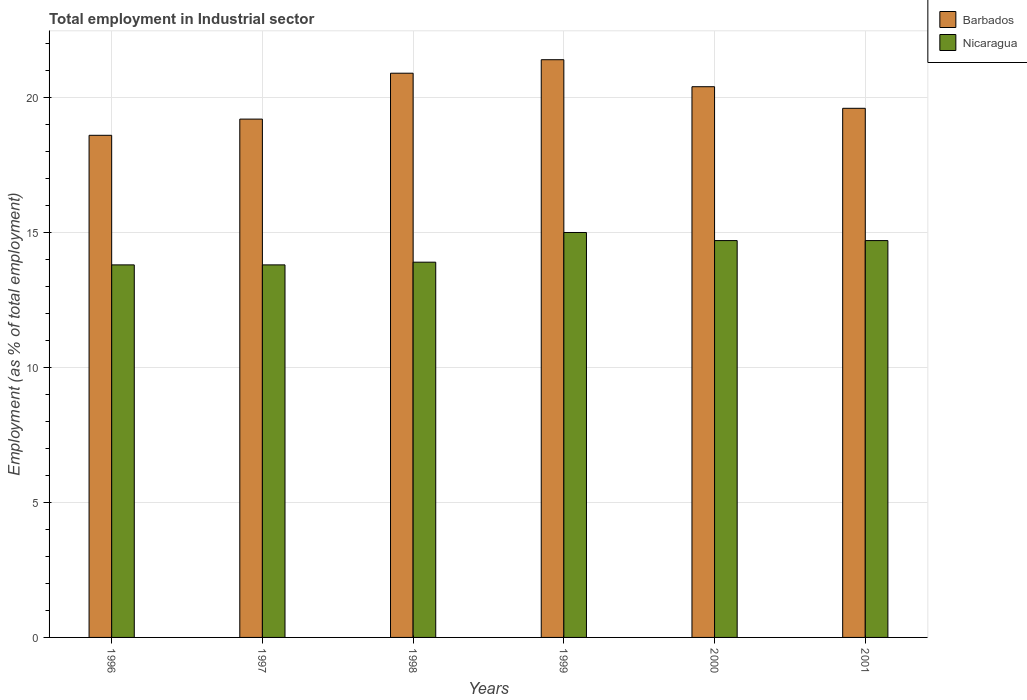How many groups of bars are there?
Your response must be concise. 6. Are the number of bars per tick equal to the number of legend labels?
Your answer should be compact. Yes. How many bars are there on the 2nd tick from the left?
Provide a succinct answer. 2. What is the label of the 5th group of bars from the left?
Ensure brevity in your answer.  2000. In how many cases, is the number of bars for a given year not equal to the number of legend labels?
Provide a succinct answer. 0. What is the employment in industrial sector in Nicaragua in 2001?
Your answer should be compact. 14.7. Across all years, what is the minimum employment in industrial sector in Nicaragua?
Your answer should be compact. 13.8. In which year was the employment in industrial sector in Barbados maximum?
Offer a terse response. 1999. In which year was the employment in industrial sector in Barbados minimum?
Provide a succinct answer. 1996. What is the total employment in industrial sector in Nicaragua in the graph?
Your response must be concise. 85.9. What is the difference between the employment in industrial sector in Barbados in 1997 and that in 2001?
Make the answer very short. -0.4. What is the difference between the employment in industrial sector in Nicaragua in 1998 and the employment in industrial sector in Barbados in 1996?
Offer a terse response. -4.7. What is the average employment in industrial sector in Nicaragua per year?
Offer a terse response. 14.32. In the year 1999, what is the difference between the employment in industrial sector in Barbados and employment in industrial sector in Nicaragua?
Offer a very short reply. 6.4. What is the ratio of the employment in industrial sector in Barbados in 1996 to that in 1997?
Give a very brief answer. 0.97. Is the difference between the employment in industrial sector in Barbados in 1998 and 1999 greater than the difference between the employment in industrial sector in Nicaragua in 1998 and 1999?
Ensure brevity in your answer.  Yes. What is the difference between the highest and the second highest employment in industrial sector in Nicaragua?
Keep it short and to the point. 0.3. What is the difference between the highest and the lowest employment in industrial sector in Nicaragua?
Offer a terse response. 1.2. Is the sum of the employment in industrial sector in Nicaragua in 2000 and 2001 greater than the maximum employment in industrial sector in Barbados across all years?
Ensure brevity in your answer.  Yes. What does the 1st bar from the left in 1998 represents?
Your response must be concise. Barbados. What does the 2nd bar from the right in 2001 represents?
Your answer should be very brief. Barbados. Are the values on the major ticks of Y-axis written in scientific E-notation?
Give a very brief answer. No. Does the graph contain grids?
Keep it short and to the point. Yes. How are the legend labels stacked?
Your answer should be very brief. Vertical. What is the title of the graph?
Make the answer very short. Total employment in Industrial sector. Does "Bolivia" appear as one of the legend labels in the graph?
Give a very brief answer. No. What is the label or title of the X-axis?
Give a very brief answer. Years. What is the label or title of the Y-axis?
Your answer should be very brief. Employment (as % of total employment). What is the Employment (as % of total employment) of Barbados in 1996?
Your response must be concise. 18.6. What is the Employment (as % of total employment) in Nicaragua in 1996?
Offer a terse response. 13.8. What is the Employment (as % of total employment) of Barbados in 1997?
Your response must be concise. 19.2. What is the Employment (as % of total employment) of Nicaragua in 1997?
Your response must be concise. 13.8. What is the Employment (as % of total employment) in Barbados in 1998?
Your response must be concise. 20.9. What is the Employment (as % of total employment) in Nicaragua in 1998?
Provide a succinct answer. 13.9. What is the Employment (as % of total employment) of Barbados in 1999?
Make the answer very short. 21.4. What is the Employment (as % of total employment) in Nicaragua in 1999?
Make the answer very short. 15. What is the Employment (as % of total employment) in Barbados in 2000?
Make the answer very short. 20.4. What is the Employment (as % of total employment) of Nicaragua in 2000?
Provide a short and direct response. 14.7. What is the Employment (as % of total employment) of Barbados in 2001?
Provide a short and direct response. 19.6. What is the Employment (as % of total employment) in Nicaragua in 2001?
Your answer should be very brief. 14.7. Across all years, what is the maximum Employment (as % of total employment) in Barbados?
Your response must be concise. 21.4. Across all years, what is the minimum Employment (as % of total employment) of Barbados?
Provide a short and direct response. 18.6. Across all years, what is the minimum Employment (as % of total employment) of Nicaragua?
Make the answer very short. 13.8. What is the total Employment (as % of total employment) in Barbados in the graph?
Keep it short and to the point. 120.1. What is the total Employment (as % of total employment) in Nicaragua in the graph?
Provide a succinct answer. 85.9. What is the difference between the Employment (as % of total employment) in Barbados in 1996 and that in 1998?
Give a very brief answer. -2.3. What is the difference between the Employment (as % of total employment) of Barbados in 1996 and that in 1999?
Ensure brevity in your answer.  -2.8. What is the difference between the Employment (as % of total employment) in Nicaragua in 1996 and that in 1999?
Your answer should be very brief. -1.2. What is the difference between the Employment (as % of total employment) in Barbados in 1996 and that in 2000?
Give a very brief answer. -1.8. What is the difference between the Employment (as % of total employment) of Barbados in 1996 and that in 2001?
Give a very brief answer. -1. What is the difference between the Employment (as % of total employment) of Nicaragua in 1997 and that in 2000?
Keep it short and to the point. -0.9. What is the difference between the Employment (as % of total employment) in Nicaragua in 1998 and that in 2000?
Offer a terse response. -0.8. What is the difference between the Employment (as % of total employment) in Barbados in 1998 and that in 2001?
Offer a very short reply. 1.3. What is the difference between the Employment (as % of total employment) of Nicaragua in 1998 and that in 2001?
Provide a succinct answer. -0.8. What is the difference between the Employment (as % of total employment) of Barbados in 1999 and that in 2000?
Keep it short and to the point. 1. What is the difference between the Employment (as % of total employment) in Barbados in 2000 and that in 2001?
Give a very brief answer. 0.8. What is the difference between the Employment (as % of total employment) of Nicaragua in 2000 and that in 2001?
Offer a very short reply. 0. What is the difference between the Employment (as % of total employment) of Barbados in 1996 and the Employment (as % of total employment) of Nicaragua in 1998?
Offer a terse response. 4.7. What is the difference between the Employment (as % of total employment) in Barbados in 1996 and the Employment (as % of total employment) in Nicaragua in 1999?
Offer a very short reply. 3.6. What is the difference between the Employment (as % of total employment) in Barbados in 1996 and the Employment (as % of total employment) in Nicaragua in 2001?
Provide a succinct answer. 3.9. What is the difference between the Employment (as % of total employment) of Barbados in 1997 and the Employment (as % of total employment) of Nicaragua in 1999?
Your response must be concise. 4.2. What is the difference between the Employment (as % of total employment) of Barbados in 1997 and the Employment (as % of total employment) of Nicaragua in 2001?
Your response must be concise. 4.5. What is the difference between the Employment (as % of total employment) of Barbados in 1998 and the Employment (as % of total employment) of Nicaragua in 2000?
Offer a terse response. 6.2. What is the difference between the Employment (as % of total employment) of Barbados in 1999 and the Employment (as % of total employment) of Nicaragua in 2000?
Offer a terse response. 6.7. What is the difference between the Employment (as % of total employment) of Barbados in 1999 and the Employment (as % of total employment) of Nicaragua in 2001?
Offer a terse response. 6.7. What is the difference between the Employment (as % of total employment) of Barbados in 2000 and the Employment (as % of total employment) of Nicaragua in 2001?
Provide a succinct answer. 5.7. What is the average Employment (as % of total employment) in Barbados per year?
Your response must be concise. 20.02. What is the average Employment (as % of total employment) of Nicaragua per year?
Offer a terse response. 14.32. In the year 1997, what is the difference between the Employment (as % of total employment) in Barbados and Employment (as % of total employment) in Nicaragua?
Your answer should be very brief. 5.4. In the year 1999, what is the difference between the Employment (as % of total employment) of Barbados and Employment (as % of total employment) of Nicaragua?
Your response must be concise. 6.4. In the year 2001, what is the difference between the Employment (as % of total employment) in Barbados and Employment (as % of total employment) in Nicaragua?
Your answer should be compact. 4.9. What is the ratio of the Employment (as % of total employment) of Barbados in 1996 to that in 1997?
Your response must be concise. 0.97. What is the ratio of the Employment (as % of total employment) of Barbados in 1996 to that in 1998?
Give a very brief answer. 0.89. What is the ratio of the Employment (as % of total employment) in Nicaragua in 1996 to that in 1998?
Give a very brief answer. 0.99. What is the ratio of the Employment (as % of total employment) of Barbados in 1996 to that in 1999?
Your answer should be compact. 0.87. What is the ratio of the Employment (as % of total employment) in Nicaragua in 1996 to that in 1999?
Make the answer very short. 0.92. What is the ratio of the Employment (as % of total employment) of Barbados in 1996 to that in 2000?
Keep it short and to the point. 0.91. What is the ratio of the Employment (as % of total employment) of Nicaragua in 1996 to that in 2000?
Your answer should be compact. 0.94. What is the ratio of the Employment (as % of total employment) of Barbados in 1996 to that in 2001?
Keep it short and to the point. 0.95. What is the ratio of the Employment (as % of total employment) of Nicaragua in 1996 to that in 2001?
Offer a terse response. 0.94. What is the ratio of the Employment (as % of total employment) of Barbados in 1997 to that in 1998?
Keep it short and to the point. 0.92. What is the ratio of the Employment (as % of total employment) of Nicaragua in 1997 to that in 1998?
Offer a terse response. 0.99. What is the ratio of the Employment (as % of total employment) in Barbados in 1997 to that in 1999?
Provide a succinct answer. 0.9. What is the ratio of the Employment (as % of total employment) in Nicaragua in 1997 to that in 2000?
Your response must be concise. 0.94. What is the ratio of the Employment (as % of total employment) of Barbados in 1997 to that in 2001?
Ensure brevity in your answer.  0.98. What is the ratio of the Employment (as % of total employment) of Nicaragua in 1997 to that in 2001?
Offer a terse response. 0.94. What is the ratio of the Employment (as % of total employment) of Barbados in 1998 to that in 1999?
Your answer should be compact. 0.98. What is the ratio of the Employment (as % of total employment) in Nicaragua in 1998 to that in 1999?
Ensure brevity in your answer.  0.93. What is the ratio of the Employment (as % of total employment) in Barbados in 1998 to that in 2000?
Ensure brevity in your answer.  1.02. What is the ratio of the Employment (as % of total employment) of Nicaragua in 1998 to that in 2000?
Your answer should be compact. 0.95. What is the ratio of the Employment (as % of total employment) in Barbados in 1998 to that in 2001?
Provide a succinct answer. 1.07. What is the ratio of the Employment (as % of total employment) in Nicaragua in 1998 to that in 2001?
Keep it short and to the point. 0.95. What is the ratio of the Employment (as % of total employment) of Barbados in 1999 to that in 2000?
Offer a terse response. 1.05. What is the ratio of the Employment (as % of total employment) in Nicaragua in 1999 to that in 2000?
Your response must be concise. 1.02. What is the ratio of the Employment (as % of total employment) of Barbados in 1999 to that in 2001?
Keep it short and to the point. 1.09. What is the ratio of the Employment (as % of total employment) in Nicaragua in 1999 to that in 2001?
Your answer should be very brief. 1.02. What is the ratio of the Employment (as % of total employment) of Barbados in 2000 to that in 2001?
Provide a short and direct response. 1.04. What is the difference between the highest and the lowest Employment (as % of total employment) in Barbados?
Ensure brevity in your answer.  2.8. What is the difference between the highest and the lowest Employment (as % of total employment) of Nicaragua?
Give a very brief answer. 1.2. 